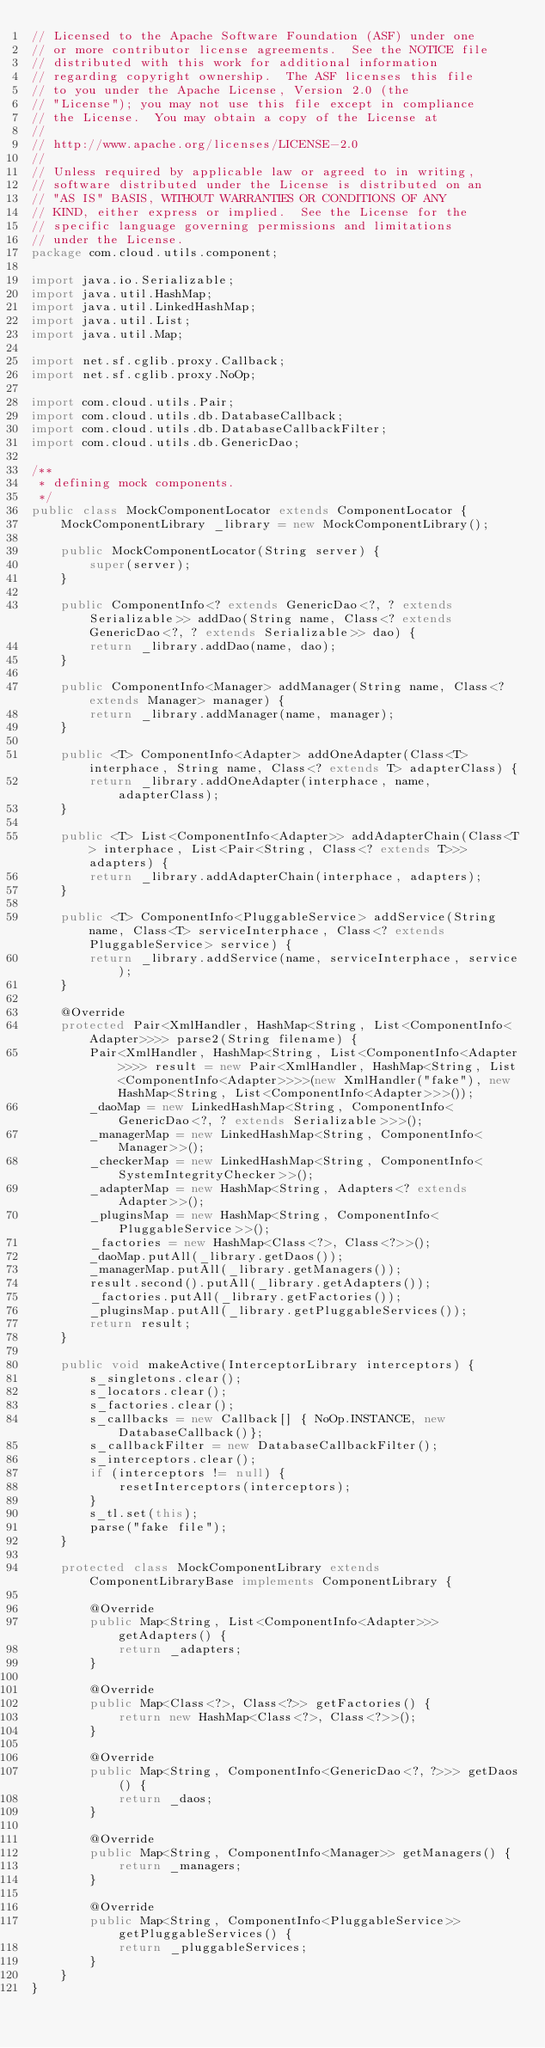<code> <loc_0><loc_0><loc_500><loc_500><_Java_>// Licensed to the Apache Software Foundation (ASF) under one
// or more contributor license agreements.  See the NOTICE file
// distributed with this work for additional information
// regarding copyright ownership.  The ASF licenses this file
// to you under the Apache License, Version 2.0 (the
// "License"); you may not use this file except in compliance
// the License.  You may obtain a copy of the License at
//
// http://www.apache.org/licenses/LICENSE-2.0
//
// Unless required by applicable law or agreed to in writing,
// software distributed under the License is distributed on an
// "AS IS" BASIS, WITHOUT WARRANTIES OR CONDITIONS OF ANY
// KIND, either express or implied.  See the License for the
// specific language governing permissions and limitations
// under the License.
package com.cloud.utils.component;

import java.io.Serializable;
import java.util.HashMap;
import java.util.LinkedHashMap;
import java.util.List;
import java.util.Map;

import net.sf.cglib.proxy.Callback;
import net.sf.cglib.proxy.NoOp;

import com.cloud.utils.Pair;
import com.cloud.utils.db.DatabaseCallback;
import com.cloud.utils.db.DatabaseCallbackFilter;
import com.cloud.utils.db.GenericDao;

/**
 * defining mock components.
 */
public class MockComponentLocator extends ComponentLocator {
    MockComponentLibrary _library = new MockComponentLibrary();

    public MockComponentLocator(String server) {
        super(server);
    }

    public ComponentInfo<? extends GenericDao<?, ? extends Serializable>> addDao(String name, Class<? extends GenericDao<?, ? extends Serializable>> dao) {
        return _library.addDao(name, dao);
    }

    public ComponentInfo<Manager> addManager(String name, Class<? extends Manager> manager) {
        return _library.addManager(name, manager);
    }

    public <T> ComponentInfo<Adapter> addOneAdapter(Class<T> interphace, String name, Class<? extends T> adapterClass) {
        return _library.addOneAdapter(interphace, name, adapterClass);
    }

    public <T> List<ComponentInfo<Adapter>> addAdapterChain(Class<T> interphace, List<Pair<String, Class<? extends T>>> adapters) {
        return _library.addAdapterChain(interphace, adapters);
    }

    public <T> ComponentInfo<PluggableService> addService(String name, Class<T> serviceInterphace, Class<? extends PluggableService> service) {
        return _library.addService(name, serviceInterphace, service);
    }

    @Override
    protected Pair<XmlHandler, HashMap<String, List<ComponentInfo<Adapter>>>> parse2(String filename) {
        Pair<XmlHandler, HashMap<String, List<ComponentInfo<Adapter>>>> result = new Pair<XmlHandler, HashMap<String, List<ComponentInfo<Adapter>>>>(new XmlHandler("fake"), new HashMap<String, List<ComponentInfo<Adapter>>>());
        _daoMap = new LinkedHashMap<String, ComponentInfo<GenericDao<?, ? extends Serializable>>>();
        _managerMap = new LinkedHashMap<String, ComponentInfo<Manager>>();
        _checkerMap = new LinkedHashMap<String, ComponentInfo<SystemIntegrityChecker>>();
        _adapterMap = new HashMap<String, Adapters<? extends Adapter>>();
        _pluginsMap = new HashMap<String, ComponentInfo<PluggableService>>();
        _factories = new HashMap<Class<?>, Class<?>>();
        _daoMap.putAll(_library.getDaos());
        _managerMap.putAll(_library.getManagers());
        result.second().putAll(_library.getAdapters());
        _factories.putAll(_library.getFactories());
        _pluginsMap.putAll(_library.getPluggableServices());
        return result;
    } 

    public void makeActive(InterceptorLibrary interceptors) {
        s_singletons.clear();
        s_locators.clear();
        s_factories.clear();
        s_callbacks = new Callback[] { NoOp.INSTANCE, new DatabaseCallback()};
        s_callbackFilter = new DatabaseCallbackFilter();
        s_interceptors.clear();
        if (interceptors != null) {
            resetInterceptors(interceptors);
        }
        s_tl.set(this);
        parse("fake file");
    }

    protected class MockComponentLibrary extends ComponentLibraryBase implements ComponentLibrary { 

        @Override
        public Map<String, List<ComponentInfo<Adapter>>> getAdapters() {
            return _adapters;
        }

        @Override
        public Map<Class<?>, Class<?>> getFactories() {
            return new HashMap<Class<?>, Class<?>>();
        }

        @Override
        public Map<String, ComponentInfo<GenericDao<?, ?>>> getDaos() {
            return _daos;
        }

        @Override
        public Map<String, ComponentInfo<Manager>> getManagers() {
            return _managers;
        }

        @Override
        public Map<String, ComponentInfo<PluggableService>> getPluggableServices() {
            return _pluggableServices;
        }
    }
}
</code> 